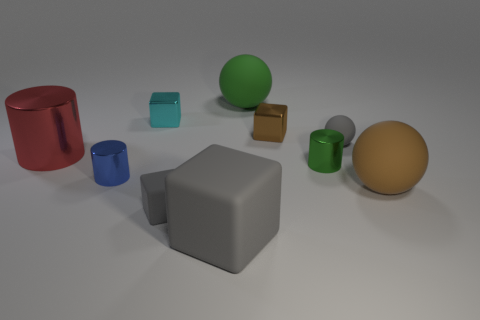Subtract all cylinders. How many objects are left? 7 Subtract all small green metallic cylinders. Subtract all balls. How many objects are left? 6 Add 5 rubber balls. How many rubber balls are left? 8 Add 1 yellow spheres. How many yellow spheres exist? 1 Subtract 1 cyan blocks. How many objects are left? 9 